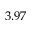Convert formula to latex. <formula><loc_0><loc_0><loc_500><loc_500>3 . 9 7</formula> 